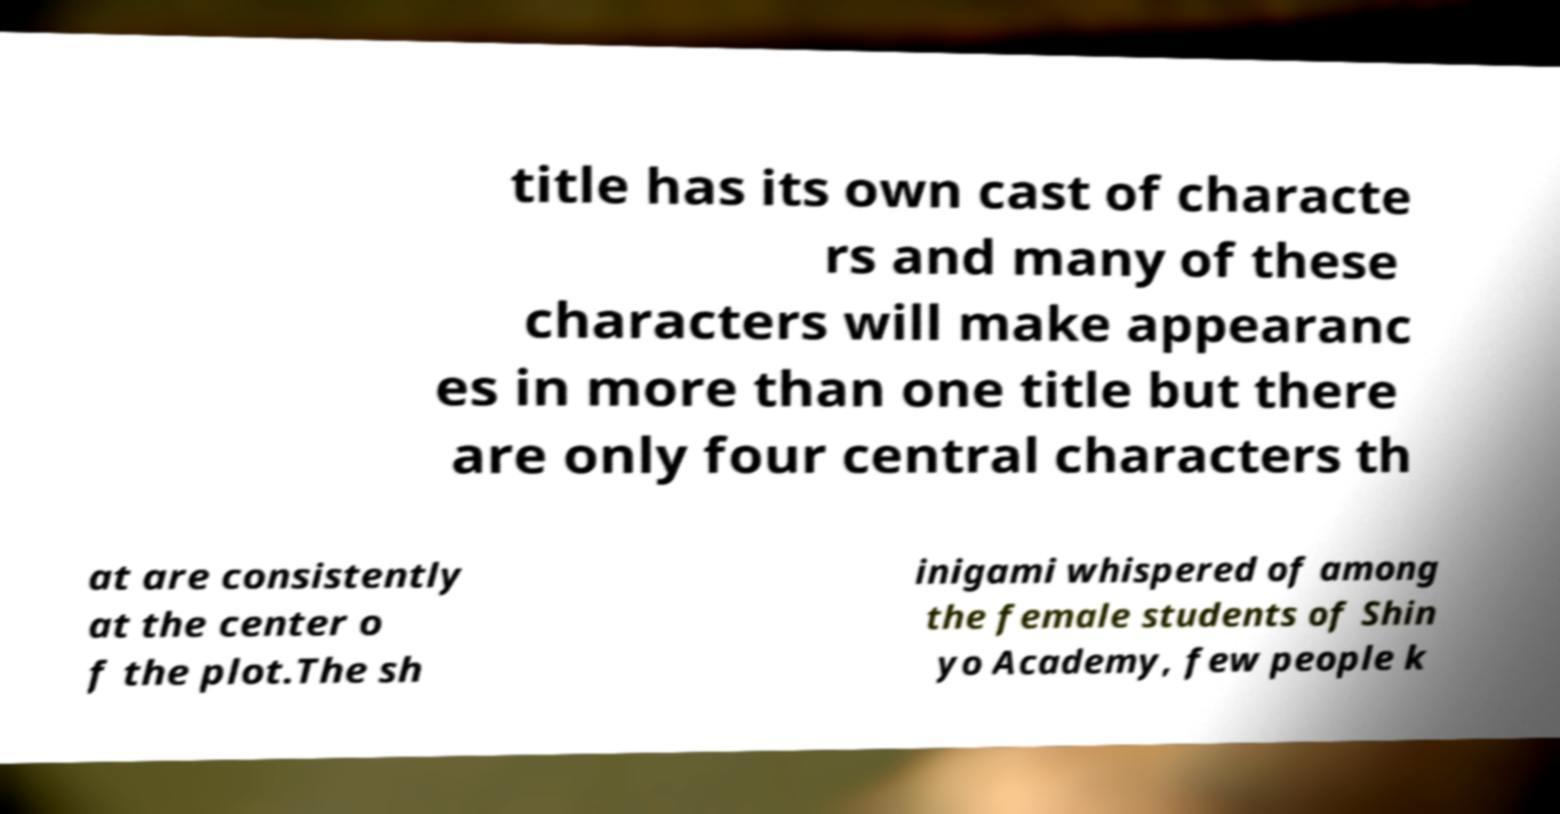Please identify and transcribe the text found in this image. title has its own cast of characte rs and many of these characters will make appearanc es in more than one title but there are only four central characters th at are consistently at the center o f the plot.The sh inigami whispered of among the female students of Shin yo Academy, few people k 